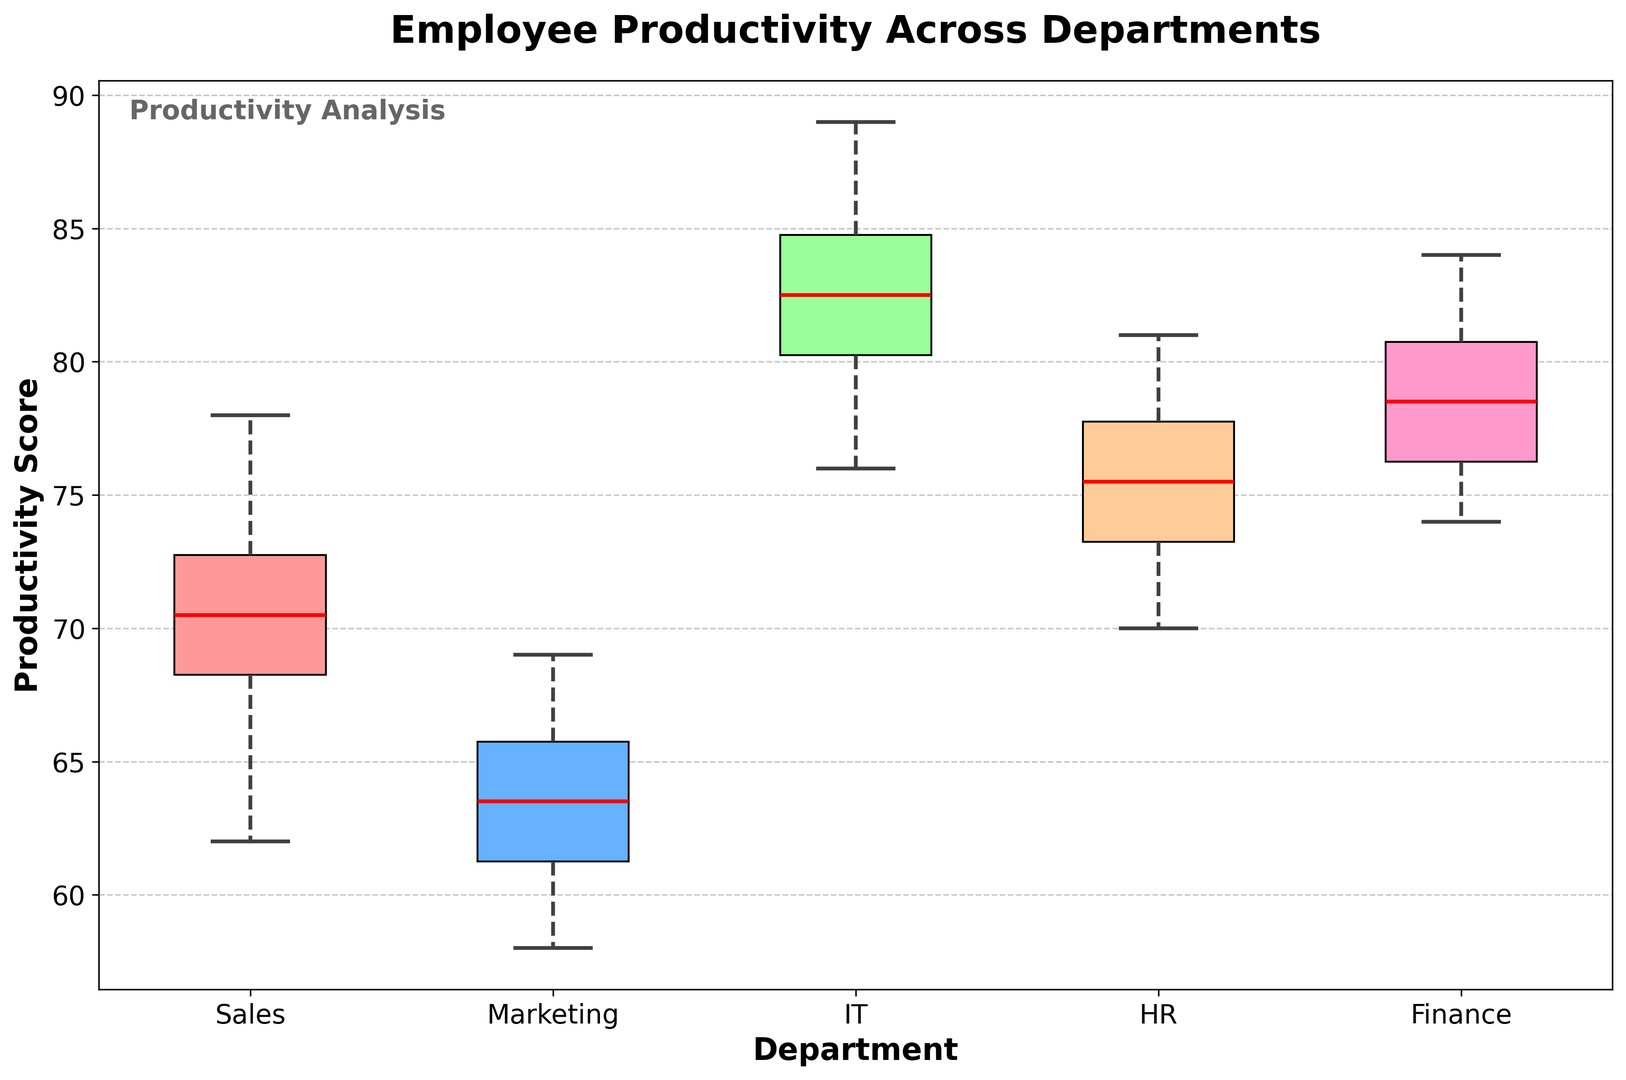what is the median productivity score for IT? The median score is found by arranging the IT scores in ascending order (76, 78, 80, 81, 82, 83, 84, 85, 87, 89) and identifying the middle value. Since we have an even number of data points, the median is the average of the 5th and 6th values: (82+83)/2.
Answer: 82.5 Which department has the highest median productivity score? To determine the department with the highest median productivity score, we compare the medians of each department. Based on the box plot, IT has the highest median productivity score.
Answer: IT How does the range of productivity scores in Marketing compare to that in Sales? The range is the difference between the highest and lowest scores in each department. For Marketing, range = 69 - 58 = 11. For Sales, range = 78 - 62 = 16. Comparing these, the range for Sales is larger.
Answer: Sales has a larger range Which department shows the most variation in productivity scores? Variation in box plots can be inferred from the interquartile range (IQR), represented by the width of the box. The department with the widest box (largest IQR) shows the most variation. Based on the visual attributes, Sales has the widest box.
Answer: Sales Which department has the least variation in productivity scores? The department with the narrowest box (smallest IQR) shows the least variation. Based on the visual attributes, IT has the narrowest box.
Answer: IT Is there any department where the median productivity score is below 70? We look at the median line within each box plot to see if it falls below the 70 mark. Based on the visual, Marketing's and HR's median productivity scores are below 70.
Answer: Marketing and HR What is the difference between the highest and lowest productivity scores in Finance? From the box plot, Finance's highest point is 84 and its lowest is 74. The difference is 84 - 74 = 10.
Answer: 10 Which department has the highest upper whisker? The upper whisker extends to the highest value within a department (excluding outliers). By visually inspecting the lengths, IT's upper whisker is the highest, reaching up to 89.
Answer: IT Which department has the lowest lower whisker? The lower whisker extends to the lowest value within a department (excluding outliers). By visually inspecting the lengths, Marketing's lower whisker is the lowest, reaching down to 58.
Answer: Marketing How does the upper quartile in HR compare to that in Sales? The upper quartile (75th percentile) is the top edge of the box in each plot. Comparing the heights, HR's upper quartile is slightly above 77 and Sales' is about 73. This makes HR's upper quartile higher than Sales'.
Answer: HR 